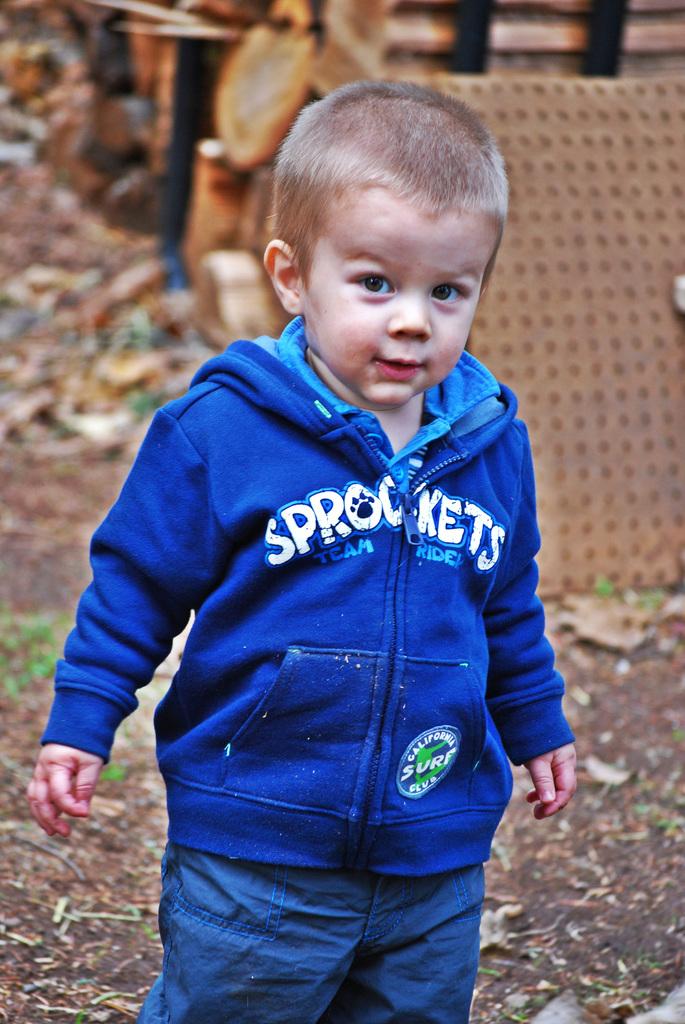What word is on the patch on the bottom of the sweatshirt?
Make the answer very short. Surf. 